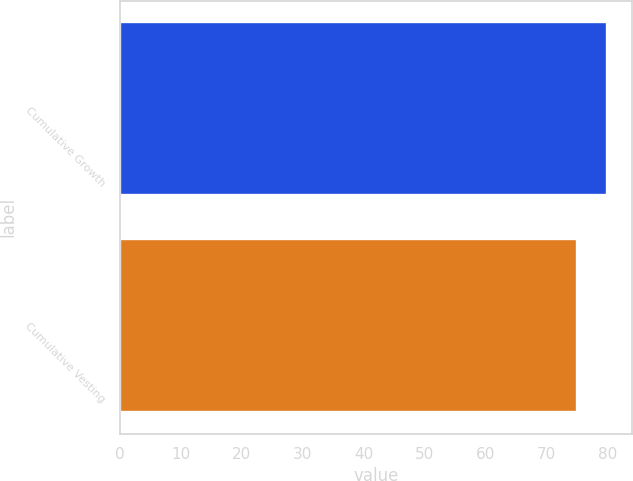Convert chart. <chart><loc_0><loc_0><loc_500><loc_500><bar_chart><fcel>Cumulative Growth<fcel>Cumulative Vesting<nl><fcel>80<fcel>75<nl></chart> 